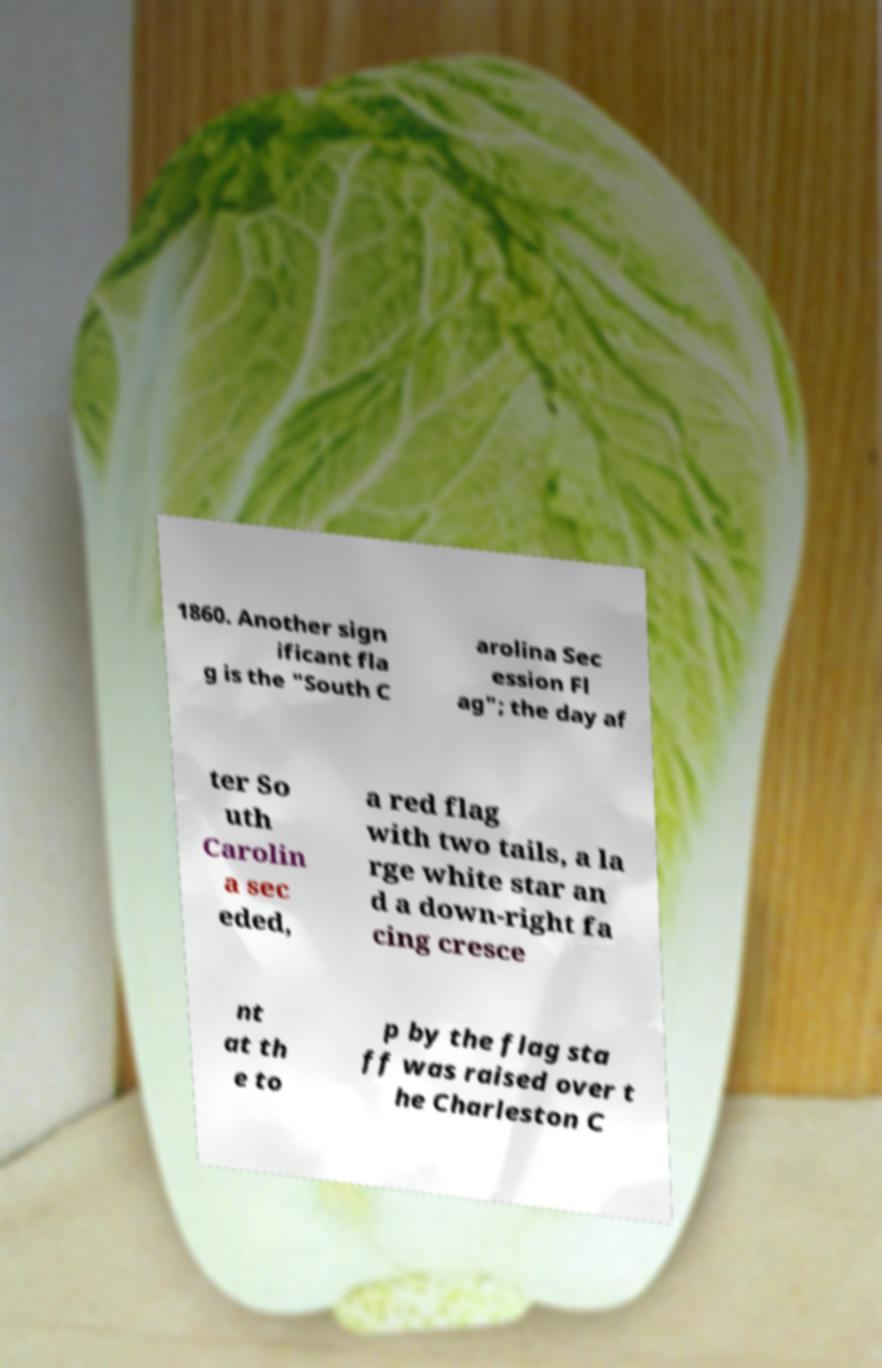Can you read and provide the text displayed in the image?This photo seems to have some interesting text. Can you extract and type it out for me? 1860. Another sign ificant fla g is the "South C arolina Sec ession Fl ag"; the day af ter So uth Carolin a sec eded, a red flag with two tails, a la rge white star an d a down-right fa cing cresce nt at th e to p by the flag sta ff was raised over t he Charleston C 